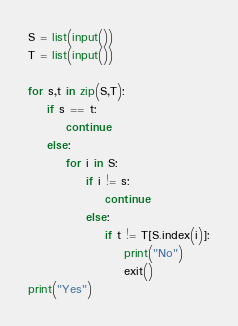<code> <loc_0><loc_0><loc_500><loc_500><_Python_>S = list(input())
T = list(input())

for s,t in zip(S,T):
    if s == t:
        continue
    else:
        for i in S:
            if i != s:
                continue
            else:
                if t != T[S.index(i)]:
                    print("No")
                    exit()
print("Yes")
</code> 